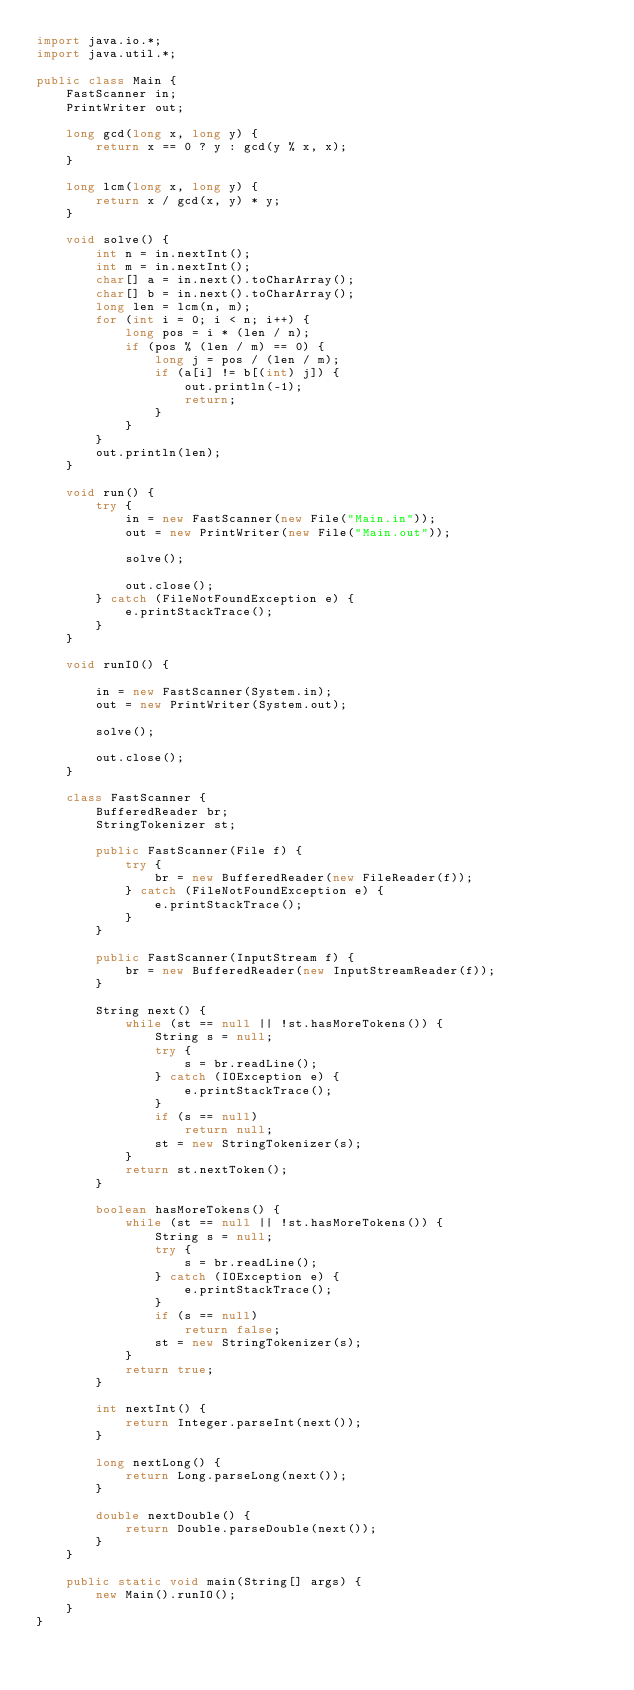<code> <loc_0><loc_0><loc_500><loc_500><_Java_>import java.io.*;
import java.util.*;

public class Main {
    FastScanner in;
    PrintWriter out;

    long gcd(long x, long y) {
        return x == 0 ? y : gcd(y % x, x);
    }

    long lcm(long x, long y) {
        return x / gcd(x, y) * y;
    }

    void solve() {
        int n = in.nextInt();
        int m = in.nextInt();
        char[] a = in.next().toCharArray();
        char[] b = in.next().toCharArray();
        long len = lcm(n, m);
        for (int i = 0; i < n; i++) {
            long pos = i * (len / n);
            if (pos % (len / m) == 0) {
                long j = pos / (len / m);
                if (a[i] != b[(int) j]) {
                    out.println(-1);
                    return;
                }
            }
        }
        out.println(len);
    }

    void run() {
        try {
            in = new FastScanner(new File("Main.in"));
            out = new PrintWriter(new File("Main.out"));

            solve();

            out.close();
        } catch (FileNotFoundException e) {
            e.printStackTrace();
        }
    }

    void runIO() {

        in = new FastScanner(System.in);
        out = new PrintWriter(System.out);

        solve();

        out.close();
    }

    class FastScanner {
        BufferedReader br;
        StringTokenizer st;

        public FastScanner(File f) {
            try {
                br = new BufferedReader(new FileReader(f));
            } catch (FileNotFoundException e) {
                e.printStackTrace();
            }
        }

        public FastScanner(InputStream f) {
            br = new BufferedReader(new InputStreamReader(f));
        }

        String next() {
            while (st == null || !st.hasMoreTokens()) {
                String s = null;
                try {
                    s = br.readLine();
                } catch (IOException e) {
                    e.printStackTrace();
                }
                if (s == null)
                    return null;
                st = new StringTokenizer(s);
            }
            return st.nextToken();
        }

        boolean hasMoreTokens() {
            while (st == null || !st.hasMoreTokens()) {
                String s = null;
                try {
                    s = br.readLine();
                } catch (IOException e) {
                    e.printStackTrace();
                }
                if (s == null)
                    return false;
                st = new StringTokenizer(s);
            }
            return true;
        }

        int nextInt() {
            return Integer.parseInt(next());
        }

        long nextLong() {
            return Long.parseLong(next());
        }

        double nextDouble() {
            return Double.parseDouble(next());
        }
    }

    public static void main(String[] args) {
        new Main().runIO();
    }
}</code> 